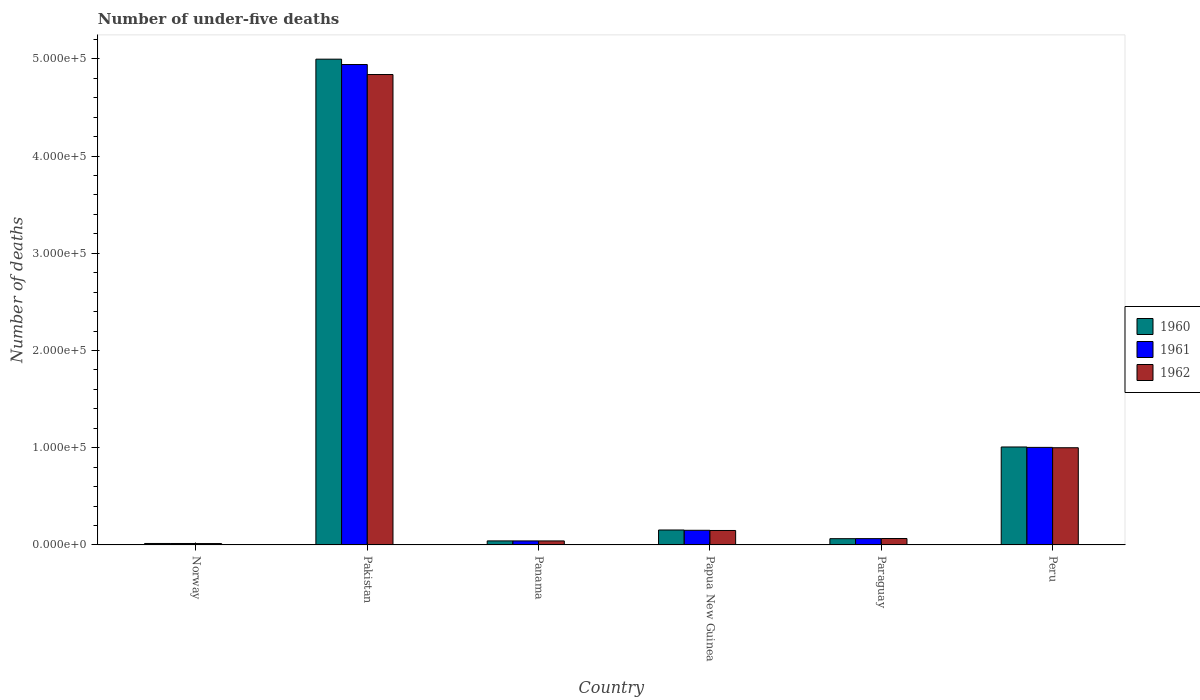How many different coloured bars are there?
Offer a very short reply. 3. Are the number of bars per tick equal to the number of legend labels?
Your answer should be very brief. Yes. Are the number of bars on each tick of the X-axis equal?
Your answer should be compact. Yes. How many bars are there on the 3rd tick from the left?
Your answer should be very brief. 3. What is the label of the 1st group of bars from the left?
Offer a terse response. Norway. What is the number of under-five deaths in 1960 in Panama?
Offer a very short reply. 4142. Across all countries, what is the maximum number of under-five deaths in 1962?
Offer a terse response. 4.84e+05. Across all countries, what is the minimum number of under-five deaths in 1962?
Give a very brief answer. 1422. In which country was the number of under-five deaths in 1962 maximum?
Keep it short and to the point. Pakistan. In which country was the number of under-five deaths in 1962 minimum?
Offer a very short reply. Norway. What is the total number of under-five deaths in 1960 in the graph?
Your response must be concise. 6.28e+05. What is the difference between the number of under-five deaths in 1962 in Norway and that in Peru?
Offer a very short reply. -9.86e+04. What is the difference between the number of under-five deaths in 1960 in Papua New Guinea and the number of under-five deaths in 1962 in Norway?
Make the answer very short. 1.39e+04. What is the average number of under-five deaths in 1960 per country?
Offer a very short reply. 1.05e+05. What is the difference between the number of under-five deaths of/in 1962 and number of under-five deaths of/in 1960 in Pakistan?
Make the answer very short. -1.58e+04. In how many countries, is the number of under-five deaths in 1960 greater than 20000?
Ensure brevity in your answer.  2. What is the ratio of the number of under-five deaths in 1961 in Norway to that in Papua New Guinea?
Provide a succinct answer. 0.1. What is the difference between the highest and the second highest number of under-five deaths in 1961?
Offer a terse response. 4.79e+05. What is the difference between the highest and the lowest number of under-five deaths in 1962?
Provide a short and direct response. 4.82e+05. In how many countries, is the number of under-five deaths in 1960 greater than the average number of under-five deaths in 1960 taken over all countries?
Give a very brief answer. 1. Is the sum of the number of under-five deaths in 1962 in Paraguay and Peru greater than the maximum number of under-five deaths in 1960 across all countries?
Offer a terse response. No. What does the 3rd bar from the left in Paraguay represents?
Offer a very short reply. 1962. Is it the case that in every country, the sum of the number of under-five deaths in 1962 and number of under-five deaths in 1960 is greater than the number of under-five deaths in 1961?
Offer a very short reply. Yes. Are all the bars in the graph horizontal?
Offer a very short reply. No. Are the values on the major ticks of Y-axis written in scientific E-notation?
Give a very brief answer. Yes. Does the graph contain any zero values?
Provide a short and direct response. No. Does the graph contain grids?
Offer a terse response. No. How many legend labels are there?
Ensure brevity in your answer.  3. How are the legend labels stacked?
Keep it short and to the point. Vertical. What is the title of the graph?
Keep it short and to the point. Number of under-five deaths. Does "1988" appear as one of the legend labels in the graph?
Keep it short and to the point. No. What is the label or title of the X-axis?
Offer a very short reply. Country. What is the label or title of the Y-axis?
Provide a succinct answer. Number of deaths. What is the Number of deaths of 1960 in Norway?
Offer a very short reply. 1503. What is the Number of deaths of 1961 in Norway?
Your answer should be very brief. 1480. What is the Number of deaths of 1962 in Norway?
Offer a very short reply. 1422. What is the Number of deaths in 1960 in Pakistan?
Provide a succinct answer. 5.00e+05. What is the Number of deaths in 1961 in Pakistan?
Keep it short and to the point. 4.94e+05. What is the Number of deaths in 1962 in Pakistan?
Provide a short and direct response. 4.84e+05. What is the Number of deaths of 1960 in Panama?
Provide a succinct answer. 4142. What is the Number of deaths of 1961 in Panama?
Your answer should be compact. 4139. What is the Number of deaths in 1962 in Panama?
Offer a very short reply. 4122. What is the Number of deaths of 1960 in Papua New Guinea?
Your answer should be compact. 1.54e+04. What is the Number of deaths in 1961 in Papua New Guinea?
Make the answer very short. 1.51e+04. What is the Number of deaths of 1962 in Papua New Guinea?
Provide a short and direct response. 1.49e+04. What is the Number of deaths of 1960 in Paraguay?
Provide a short and direct response. 6434. What is the Number of deaths of 1961 in Paraguay?
Your response must be concise. 6486. What is the Number of deaths of 1962 in Paraguay?
Make the answer very short. 6590. What is the Number of deaths of 1960 in Peru?
Your answer should be compact. 1.01e+05. What is the Number of deaths of 1961 in Peru?
Provide a succinct answer. 1.00e+05. What is the Number of deaths in 1962 in Peru?
Ensure brevity in your answer.  1.00e+05. Across all countries, what is the maximum Number of deaths of 1960?
Keep it short and to the point. 5.00e+05. Across all countries, what is the maximum Number of deaths in 1961?
Ensure brevity in your answer.  4.94e+05. Across all countries, what is the maximum Number of deaths of 1962?
Make the answer very short. 4.84e+05. Across all countries, what is the minimum Number of deaths in 1960?
Keep it short and to the point. 1503. Across all countries, what is the minimum Number of deaths in 1961?
Provide a short and direct response. 1480. Across all countries, what is the minimum Number of deaths in 1962?
Give a very brief answer. 1422. What is the total Number of deaths of 1960 in the graph?
Your answer should be very brief. 6.28e+05. What is the total Number of deaths of 1961 in the graph?
Your answer should be very brief. 6.22e+05. What is the total Number of deaths in 1962 in the graph?
Ensure brevity in your answer.  6.11e+05. What is the difference between the Number of deaths in 1960 in Norway and that in Pakistan?
Keep it short and to the point. -4.98e+05. What is the difference between the Number of deaths in 1961 in Norway and that in Pakistan?
Provide a short and direct response. -4.93e+05. What is the difference between the Number of deaths of 1962 in Norway and that in Pakistan?
Keep it short and to the point. -4.82e+05. What is the difference between the Number of deaths in 1960 in Norway and that in Panama?
Give a very brief answer. -2639. What is the difference between the Number of deaths in 1961 in Norway and that in Panama?
Ensure brevity in your answer.  -2659. What is the difference between the Number of deaths in 1962 in Norway and that in Panama?
Ensure brevity in your answer.  -2700. What is the difference between the Number of deaths of 1960 in Norway and that in Papua New Guinea?
Your answer should be very brief. -1.39e+04. What is the difference between the Number of deaths in 1961 in Norway and that in Papua New Guinea?
Offer a terse response. -1.36e+04. What is the difference between the Number of deaths in 1962 in Norway and that in Papua New Guinea?
Ensure brevity in your answer.  -1.34e+04. What is the difference between the Number of deaths of 1960 in Norway and that in Paraguay?
Your response must be concise. -4931. What is the difference between the Number of deaths in 1961 in Norway and that in Paraguay?
Keep it short and to the point. -5006. What is the difference between the Number of deaths in 1962 in Norway and that in Paraguay?
Your answer should be compact. -5168. What is the difference between the Number of deaths of 1960 in Norway and that in Peru?
Your answer should be very brief. -9.92e+04. What is the difference between the Number of deaths in 1961 in Norway and that in Peru?
Provide a succinct answer. -9.89e+04. What is the difference between the Number of deaths in 1962 in Norway and that in Peru?
Provide a succinct answer. -9.86e+04. What is the difference between the Number of deaths in 1960 in Pakistan and that in Panama?
Offer a terse response. 4.96e+05. What is the difference between the Number of deaths in 1961 in Pakistan and that in Panama?
Your answer should be compact. 4.90e+05. What is the difference between the Number of deaths of 1962 in Pakistan and that in Panama?
Keep it short and to the point. 4.80e+05. What is the difference between the Number of deaths of 1960 in Pakistan and that in Papua New Guinea?
Your answer should be compact. 4.84e+05. What is the difference between the Number of deaths of 1961 in Pakistan and that in Papua New Guinea?
Keep it short and to the point. 4.79e+05. What is the difference between the Number of deaths of 1962 in Pakistan and that in Papua New Guinea?
Provide a short and direct response. 4.69e+05. What is the difference between the Number of deaths in 1960 in Pakistan and that in Paraguay?
Your response must be concise. 4.93e+05. What is the difference between the Number of deaths of 1961 in Pakistan and that in Paraguay?
Make the answer very short. 4.88e+05. What is the difference between the Number of deaths in 1962 in Pakistan and that in Paraguay?
Your answer should be compact. 4.77e+05. What is the difference between the Number of deaths in 1960 in Pakistan and that in Peru?
Provide a short and direct response. 3.99e+05. What is the difference between the Number of deaths in 1961 in Pakistan and that in Peru?
Keep it short and to the point. 3.94e+05. What is the difference between the Number of deaths in 1962 in Pakistan and that in Peru?
Your response must be concise. 3.84e+05. What is the difference between the Number of deaths of 1960 in Panama and that in Papua New Guinea?
Give a very brief answer. -1.12e+04. What is the difference between the Number of deaths of 1961 in Panama and that in Papua New Guinea?
Ensure brevity in your answer.  -1.09e+04. What is the difference between the Number of deaths in 1962 in Panama and that in Papua New Guinea?
Offer a very short reply. -1.07e+04. What is the difference between the Number of deaths in 1960 in Panama and that in Paraguay?
Give a very brief answer. -2292. What is the difference between the Number of deaths of 1961 in Panama and that in Paraguay?
Your answer should be very brief. -2347. What is the difference between the Number of deaths of 1962 in Panama and that in Paraguay?
Offer a terse response. -2468. What is the difference between the Number of deaths in 1960 in Panama and that in Peru?
Keep it short and to the point. -9.66e+04. What is the difference between the Number of deaths of 1961 in Panama and that in Peru?
Your answer should be compact. -9.62e+04. What is the difference between the Number of deaths of 1962 in Panama and that in Peru?
Provide a short and direct response. -9.58e+04. What is the difference between the Number of deaths of 1960 in Papua New Guinea and that in Paraguay?
Your response must be concise. 8936. What is the difference between the Number of deaths of 1961 in Papua New Guinea and that in Paraguay?
Your response must be concise. 8582. What is the difference between the Number of deaths in 1962 in Papua New Guinea and that in Paraguay?
Ensure brevity in your answer.  8276. What is the difference between the Number of deaths of 1960 in Papua New Guinea and that in Peru?
Make the answer very short. -8.54e+04. What is the difference between the Number of deaths in 1961 in Papua New Guinea and that in Peru?
Ensure brevity in your answer.  -8.53e+04. What is the difference between the Number of deaths in 1962 in Papua New Guinea and that in Peru?
Give a very brief answer. -8.51e+04. What is the difference between the Number of deaths in 1960 in Paraguay and that in Peru?
Make the answer very short. -9.43e+04. What is the difference between the Number of deaths in 1961 in Paraguay and that in Peru?
Your answer should be very brief. -9.38e+04. What is the difference between the Number of deaths in 1962 in Paraguay and that in Peru?
Provide a succinct answer. -9.34e+04. What is the difference between the Number of deaths of 1960 in Norway and the Number of deaths of 1961 in Pakistan?
Provide a succinct answer. -4.93e+05. What is the difference between the Number of deaths of 1960 in Norway and the Number of deaths of 1962 in Pakistan?
Keep it short and to the point. -4.82e+05. What is the difference between the Number of deaths of 1961 in Norway and the Number of deaths of 1962 in Pakistan?
Give a very brief answer. -4.82e+05. What is the difference between the Number of deaths in 1960 in Norway and the Number of deaths in 1961 in Panama?
Give a very brief answer. -2636. What is the difference between the Number of deaths in 1960 in Norway and the Number of deaths in 1962 in Panama?
Give a very brief answer. -2619. What is the difference between the Number of deaths in 1961 in Norway and the Number of deaths in 1962 in Panama?
Make the answer very short. -2642. What is the difference between the Number of deaths in 1960 in Norway and the Number of deaths in 1961 in Papua New Guinea?
Your answer should be very brief. -1.36e+04. What is the difference between the Number of deaths of 1960 in Norway and the Number of deaths of 1962 in Papua New Guinea?
Give a very brief answer. -1.34e+04. What is the difference between the Number of deaths of 1961 in Norway and the Number of deaths of 1962 in Papua New Guinea?
Keep it short and to the point. -1.34e+04. What is the difference between the Number of deaths in 1960 in Norway and the Number of deaths in 1961 in Paraguay?
Keep it short and to the point. -4983. What is the difference between the Number of deaths of 1960 in Norway and the Number of deaths of 1962 in Paraguay?
Your response must be concise. -5087. What is the difference between the Number of deaths in 1961 in Norway and the Number of deaths in 1962 in Paraguay?
Ensure brevity in your answer.  -5110. What is the difference between the Number of deaths in 1960 in Norway and the Number of deaths in 1961 in Peru?
Give a very brief answer. -9.88e+04. What is the difference between the Number of deaths of 1960 in Norway and the Number of deaths of 1962 in Peru?
Your answer should be compact. -9.85e+04. What is the difference between the Number of deaths in 1961 in Norway and the Number of deaths in 1962 in Peru?
Your answer should be very brief. -9.85e+04. What is the difference between the Number of deaths of 1960 in Pakistan and the Number of deaths of 1961 in Panama?
Ensure brevity in your answer.  4.96e+05. What is the difference between the Number of deaths in 1960 in Pakistan and the Number of deaths in 1962 in Panama?
Keep it short and to the point. 4.96e+05. What is the difference between the Number of deaths of 1961 in Pakistan and the Number of deaths of 1962 in Panama?
Ensure brevity in your answer.  4.90e+05. What is the difference between the Number of deaths of 1960 in Pakistan and the Number of deaths of 1961 in Papua New Guinea?
Offer a terse response. 4.85e+05. What is the difference between the Number of deaths in 1960 in Pakistan and the Number of deaths in 1962 in Papua New Guinea?
Your answer should be very brief. 4.85e+05. What is the difference between the Number of deaths of 1961 in Pakistan and the Number of deaths of 1962 in Papua New Guinea?
Keep it short and to the point. 4.79e+05. What is the difference between the Number of deaths of 1960 in Pakistan and the Number of deaths of 1961 in Paraguay?
Your answer should be compact. 4.93e+05. What is the difference between the Number of deaths in 1960 in Pakistan and the Number of deaths in 1962 in Paraguay?
Keep it short and to the point. 4.93e+05. What is the difference between the Number of deaths of 1961 in Pakistan and the Number of deaths of 1962 in Paraguay?
Keep it short and to the point. 4.88e+05. What is the difference between the Number of deaths in 1960 in Pakistan and the Number of deaths in 1961 in Peru?
Give a very brief answer. 3.99e+05. What is the difference between the Number of deaths of 1960 in Pakistan and the Number of deaths of 1962 in Peru?
Keep it short and to the point. 4.00e+05. What is the difference between the Number of deaths in 1961 in Pakistan and the Number of deaths in 1962 in Peru?
Offer a terse response. 3.94e+05. What is the difference between the Number of deaths of 1960 in Panama and the Number of deaths of 1961 in Papua New Guinea?
Provide a short and direct response. -1.09e+04. What is the difference between the Number of deaths of 1960 in Panama and the Number of deaths of 1962 in Papua New Guinea?
Offer a terse response. -1.07e+04. What is the difference between the Number of deaths of 1961 in Panama and the Number of deaths of 1962 in Papua New Guinea?
Provide a succinct answer. -1.07e+04. What is the difference between the Number of deaths of 1960 in Panama and the Number of deaths of 1961 in Paraguay?
Your answer should be compact. -2344. What is the difference between the Number of deaths in 1960 in Panama and the Number of deaths in 1962 in Paraguay?
Provide a short and direct response. -2448. What is the difference between the Number of deaths of 1961 in Panama and the Number of deaths of 1962 in Paraguay?
Your answer should be compact. -2451. What is the difference between the Number of deaths in 1960 in Panama and the Number of deaths in 1961 in Peru?
Your answer should be very brief. -9.62e+04. What is the difference between the Number of deaths of 1960 in Panama and the Number of deaths of 1962 in Peru?
Keep it short and to the point. -9.58e+04. What is the difference between the Number of deaths of 1961 in Panama and the Number of deaths of 1962 in Peru?
Make the answer very short. -9.58e+04. What is the difference between the Number of deaths of 1960 in Papua New Guinea and the Number of deaths of 1961 in Paraguay?
Your answer should be very brief. 8884. What is the difference between the Number of deaths of 1960 in Papua New Guinea and the Number of deaths of 1962 in Paraguay?
Your answer should be compact. 8780. What is the difference between the Number of deaths in 1961 in Papua New Guinea and the Number of deaths in 1962 in Paraguay?
Provide a short and direct response. 8478. What is the difference between the Number of deaths of 1960 in Papua New Guinea and the Number of deaths of 1961 in Peru?
Your response must be concise. -8.50e+04. What is the difference between the Number of deaths of 1960 in Papua New Guinea and the Number of deaths of 1962 in Peru?
Offer a terse response. -8.46e+04. What is the difference between the Number of deaths of 1961 in Papua New Guinea and the Number of deaths of 1962 in Peru?
Offer a very short reply. -8.49e+04. What is the difference between the Number of deaths in 1960 in Paraguay and the Number of deaths in 1961 in Peru?
Your answer should be compact. -9.39e+04. What is the difference between the Number of deaths of 1960 in Paraguay and the Number of deaths of 1962 in Peru?
Offer a very short reply. -9.35e+04. What is the difference between the Number of deaths in 1961 in Paraguay and the Number of deaths in 1962 in Peru?
Your response must be concise. -9.35e+04. What is the average Number of deaths in 1960 per country?
Keep it short and to the point. 1.05e+05. What is the average Number of deaths in 1961 per country?
Offer a terse response. 1.04e+05. What is the average Number of deaths of 1962 per country?
Give a very brief answer. 1.02e+05. What is the difference between the Number of deaths of 1960 and Number of deaths of 1961 in Norway?
Ensure brevity in your answer.  23. What is the difference between the Number of deaths of 1960 and Number of deaths of 1962 in Norway?
Provide a short and direct response. 81. What is the difference between the Number of deaths of 1961 and Number of deaths of 1962 in Norway?
Offer a terse response. 58. What is the difference between the Number of deaths in 1960 and Number of deaths in 1961 in Pakistan?
Your response must be concise. 5515. What is the difference between the Number of deaths of 1960 and Number of deaths of 1962 in Pakistan?
Provide a short and direct response. 1.58e+04. What is the difference between the Number of deaths in 1961 and Number of deaths in 1962 in Pakistan?
Your response must be concise. 1.03e+04. What is the difference between the Number of deaths in 1960 and Number of deaths in 1961 in Panama?
Give a very brief answer. 3. What is the difference between the Number of deaths of 1961 and Number of deaths of 1962 in Panama?
Ensure brevity in your answer.  17. What is the difference between the Number of deaths in 1960 and Number of deaths in 1961 in Papua New Guinea?
Provide a succinct answer. 302. What is the difference between the Number of deaths in 1960 and Number of deaths in 1962 in Papua New Guinea?
Ensure brevity in your answer.  504. What is the difference between the Number of deaths in 1961 and Number of deaths in 1962 in Papua New Guinea?
Give a very brief answer. 202. What is the difference between the Number of deaths in 1960 and Number of deaths in 1961 in Paraguay?
Provide a succinct answer. -52. What is the difference between the Number of deaths in 1960 and Number of deaths in 1962 in Paraguay?
Ensure brevity in your answer.  -156. What is the difference between the Number of deaths of 1961 and Number of deaths of 1962 in Paraguay?
Ensure brevity in your answer.  -104. What is the difference between the Number of deaths of 1960 and Number of deaths of 1961 in Peru?
Offer a very short reply. 416. What is the difference between the Number of deaths of 1960 and Number of deaths of 1962 in Peru?
Give a very brief answer. 778. What is the difference between the Number of deaths in 1961 and Number of deaths in 1962 in Peru?
Your answer should be very brief. 362. What is the ratio of the Number of deaths in 1960 in Norway to that in Pakistan?
Offer a very short reply. 0. What is the ratio of the Number of deaths in 1961 in Norway to that in Pakistan?
Provide a short and direct response. 0. What is the ratio of the Number of deaths of 1962 in Norway to that in Pakistan?
Keep it short and to the point. 0. What is the ratio of the Number of deaths of 1960 in Norway to that in Panama?
Ensure brevity in your answer.  0.36. What is the ratio of the Number of deaths of 1961 in Norway to that in Panama?
Offer a very short reply. 0.36. What is the ratio of the Number of deaths in 1962 in Norway to that in Panama?
Ensure brevity in your answer.  0.34. What is the ratio of the Number of deaths of 1960 in Norway to that in Papua New Guinea?
Provide a succinct answer. 0.1. What is the ratio of the Number of deaths of 1961 in Norway to that in Papua New Guinea?
Provide a short and direct response. 0.1. What is the ratio of the Number of deaths of 1962 in Norway to that in Papua New Guinea?
Provide a short and direct response. 0.1. What is the ratio of the Number of deaths of 1960 in Norway to that in Paraguay?
Your answer should be very brief. 0.23. What is the ratio of the Number of deaths in 1961 in Norway to that in Paraguay?
Your answer should be very brief. 0.23. What is the ratio of the Number of deaths of 1962 in Norway to that in Paraguay?
Keep it short and to the point. 0.22. What is the ratio of the Number of deaths in 1960 in Norway to that in Peru?
Your answer should be very brief. 0.01. What is the ratio of the Number of deaths of 1961 in Norway to that in Peru?
Provide a short and direct response. 0.01. What is the ratio of the Number of deaths of 1962 in Norway to that in Peru?
Make the answer very short. 0.01. What is the ratio of the Number of deaths in 1960 in Pakistan to that in Panama?
Offer a very short reply. 120.63. What is the ratio of the Number of deaths in 1961 in Pakistan to that in Panama?
Offer a very short reply. 119.38. What is the ratio of the Number of deaths in 1962 in Pakistan to that in Panama?
Make the answer very short. 117.38. What is the ratio of the Number of deaths in 1960 in Pakistan to that in Papua New Guinea?
Offer a very short reply. 32.51. What is the ratio of the Number of deaths of 1961 in Pakistan to that in Papua New Guinea?
Provide a short and direct response. 32.79. What is the ratio of the Number of deaths of 1962 in Pakistan to that in Papua New Guinea?
Provide a short and direct response. 32.55. What is the ratio of the Number of deaths of 1960 in Pakistan to that in Paraguay?
Ensure brevity in your answer.  77.66. What is the ratio of the Number of deaths of 1961 in Pakistan to that in Paraguay?
Offer a very short reply. 76.18. What is the ratio of the Number of deaths in 1962 in Pakistan to that in Paraguay?
Your answer should be very brief. 73.42. What is the ratio of the Number of deaths of 1960 in Pakistan to that in Peru?
Your answer should be compact. 4.96. What is the ratio of the Number of deaths in 1961 in Pakistan to that in Peru?
Keep it short and to the point. 4.92. What is the ratio of the Number of deaths in 1962 in Pakistan to that in Peru?
Provide a succinct answer. 4.84. What is the ratio of the Number of deaths in 1960 in Panama to that in Papua New Guinea?
Provide a succinct answer. 0.27. What is the ratio of the Number of deaths in 1961 in Panama to that in Papua New Guinea?
Offer a very short reply. 0.27. What is the ratio of the Number of deaths of 1962 in Panama to that in Papua New Guinea?
Offer a very short reply. 0.28. What is the ratio of the Number of deaths in 1960 in Panama to that in Paraguay?
Your response must be concise. 0.64. What is the ratio of the Number of deaths in 1961 in Panama to that in Paraguay?
Your answer should be very brief. 0.64. What is the ratio of the Number of deaths in 1962 in Panama to that in Paraguay?
Ensure brevity in your answer.  0.63. What is the ratio of the Number of deaths in 1960 in Panama to that in Peru?
Provide a short and direct response. 0.04. What is the ratio of the Number of deaths of 1961 in Panama to that in Peru?
Provide a short and direct response. 0.04. What is the ratio of the Number of deaths in 1962 in Panama to that in Peru?
Provide a short and direct response. 0.04. What is the ratio of the Number of deaths of 1960 in Papua New Guinea to that in Paraguay?
Your answer should be very brief. 2.39. What is the ratio of the Number of deaths of 1961 in Papua New Guinea to that in Paraguay?
Your answer should be compact. 2.32. What is the ratio of the Number of deaths of 1962 in Papua New Guinea to that in Paraguay?
Your response must be concise. 2.26. What is the ratio of the Number of deaths in 1960 in Papua New Guinea to that in Peru?
Ensure brevity in your answer.  0.15. What is the ratio of the Number of deaths of 1961 in Papua New Guinea to that in Peru?
Ensure brevity in your answer.  0.15. What is the ratio of the Number of deaths in 1962 in Papua New Guinea to that in Peru?
Make the answer very short. 0.15. What is the ratio of the Number of deaths in 1960 in Paraguay to that in Peru?
Your answer should be very brief. 0.06. What is the ratio of the Number of deaths of 1961 in Paraguay to that in Peru?
Offer a terse response. 0.06. What is the ratio of the Number of deaths in 1962 in Paraguay to that in Peru?
Make the answer very short. 0.07. What is the difference between the highest and the second highest Number of deaths of 1960?
Provide a succinct answer. 3.99e+05. What is the difference between the highest and the second highest Number of deaths in 1961?
Offer a very short reply. 3.94e+05. What is the difference between the highest and the second highest Number of deaths in 1962?
Your answer should be very brief. 3.84e+05. What is the difference between the highest and the lowest Number of deaths of 1960?
Your answer should be compact. 4.98e+05. What is the difference between the highest and the lowest Number of deaths of 1961?
Your response must be concise. 4.93e+05. What is the difference between the highest and the lowest Number of deaths in 1962?
Your answer should be compact. 4.82e+05. 